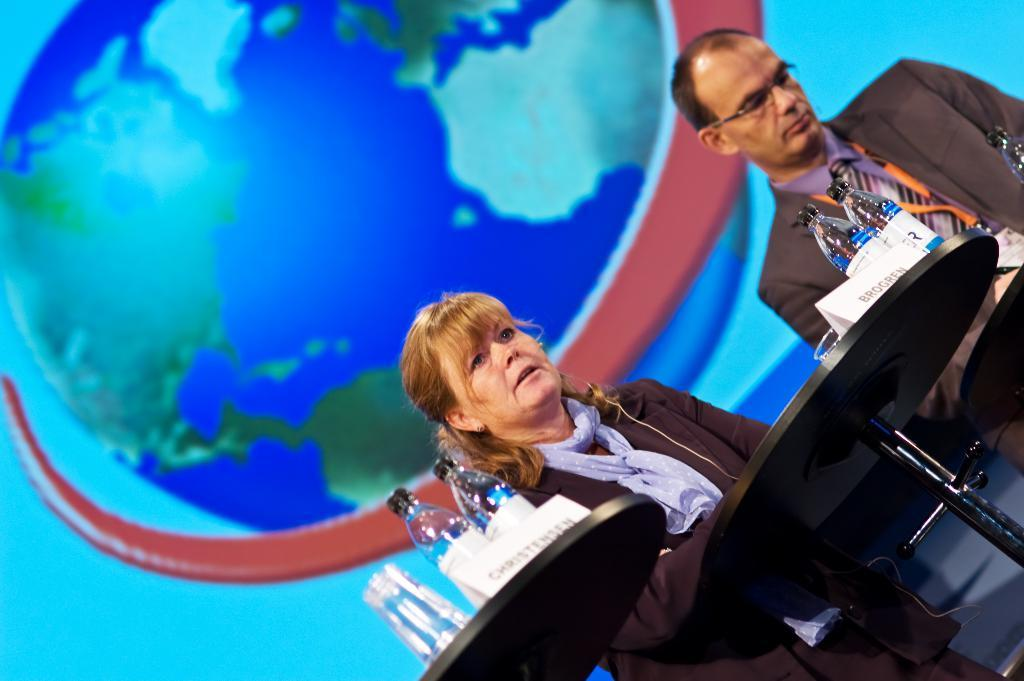How many people are in the image? There are two persons standing in front of the table. What objects can be seen on the table? There are bottles, boards, and glasses on the table. What might the people be using the boards for? The boards could be used for various purposes, such as serving food or displaying items. What can you tell about the background colors in the image? The background of the image has blue, green, and red colors. What type of bone can be seen in the image? There is no bone present in the image. How does the zephyr affect the people in the image? There is no mention of a zephyr or any wind in the image, so its effect on the people cannot be determined. 